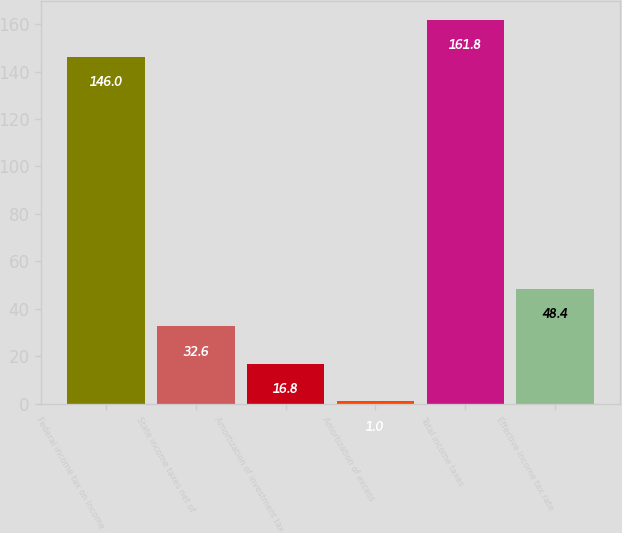Convert chart. <chart><loc_0><loc_0><loc_500><loc_500><bar_chart><fcel>Federal income tax on Income<fcel>State income taxes net of<fcel>Amortization of investment tax<fcel>Amortization of excess<fcel>Total income taxes<fcel>Effective income tax rate<nl><fcel>146<fcel>32.6<fcel>16.8<fcel>1<fcel>161.8<fcel>48.4<nl></chart> 